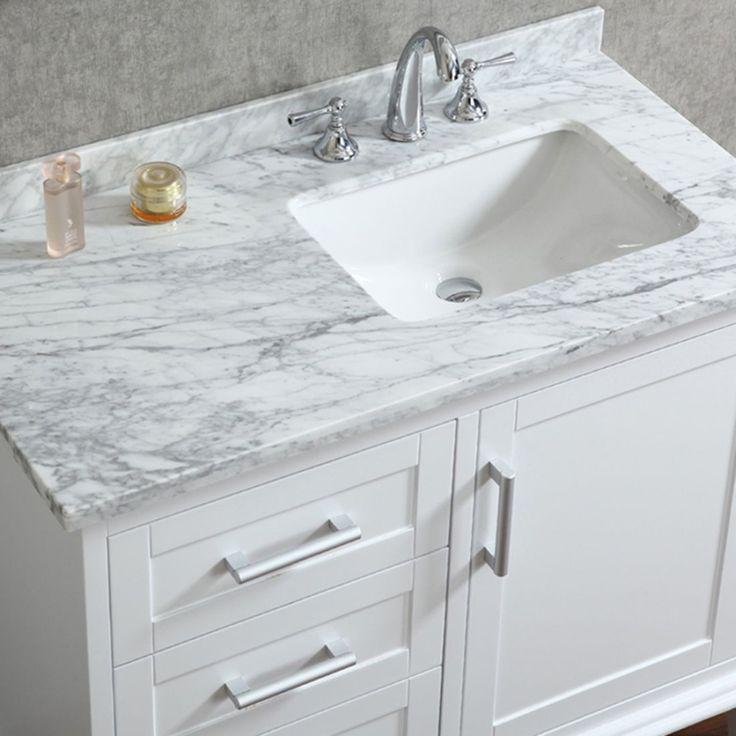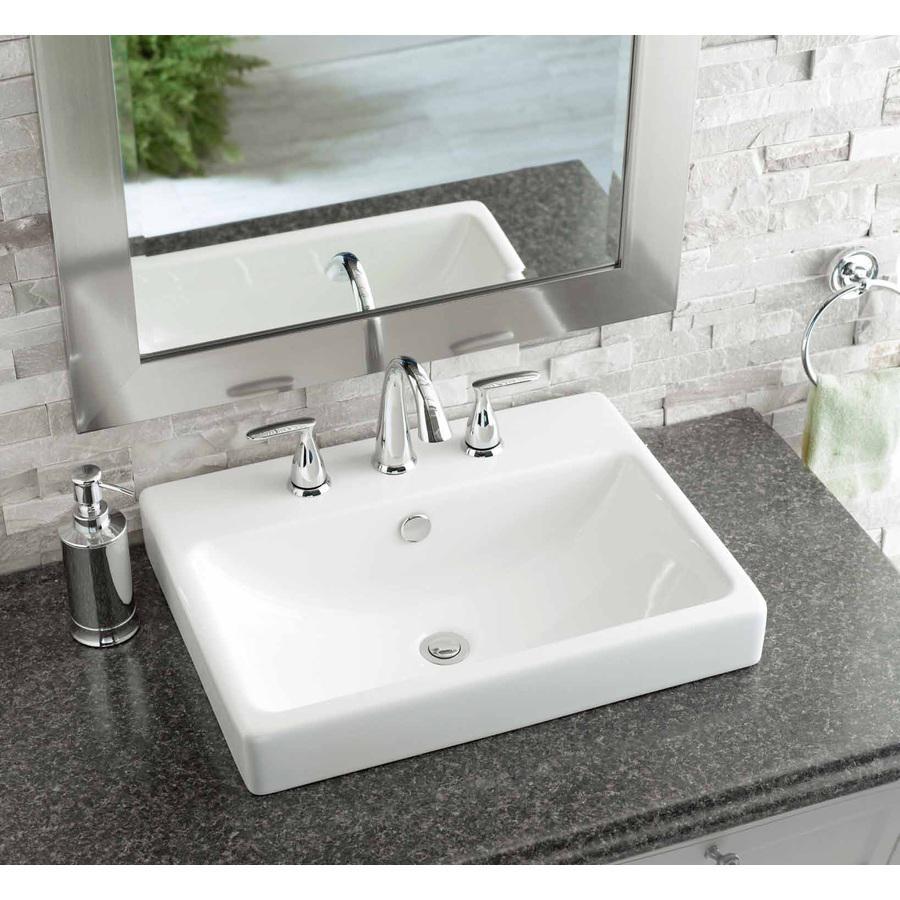The first image is the image on the left, the second image is the image on the right. Examine the images to the left and right. Is the description "there is a towel in the image on the left." accurate? Answer yes or no. No. The first image is the image on the left, the second image is the image on the right. For the images shown, is this caption "Both images feature a single-sink vanity." true? Answer yes or no. Yes. 